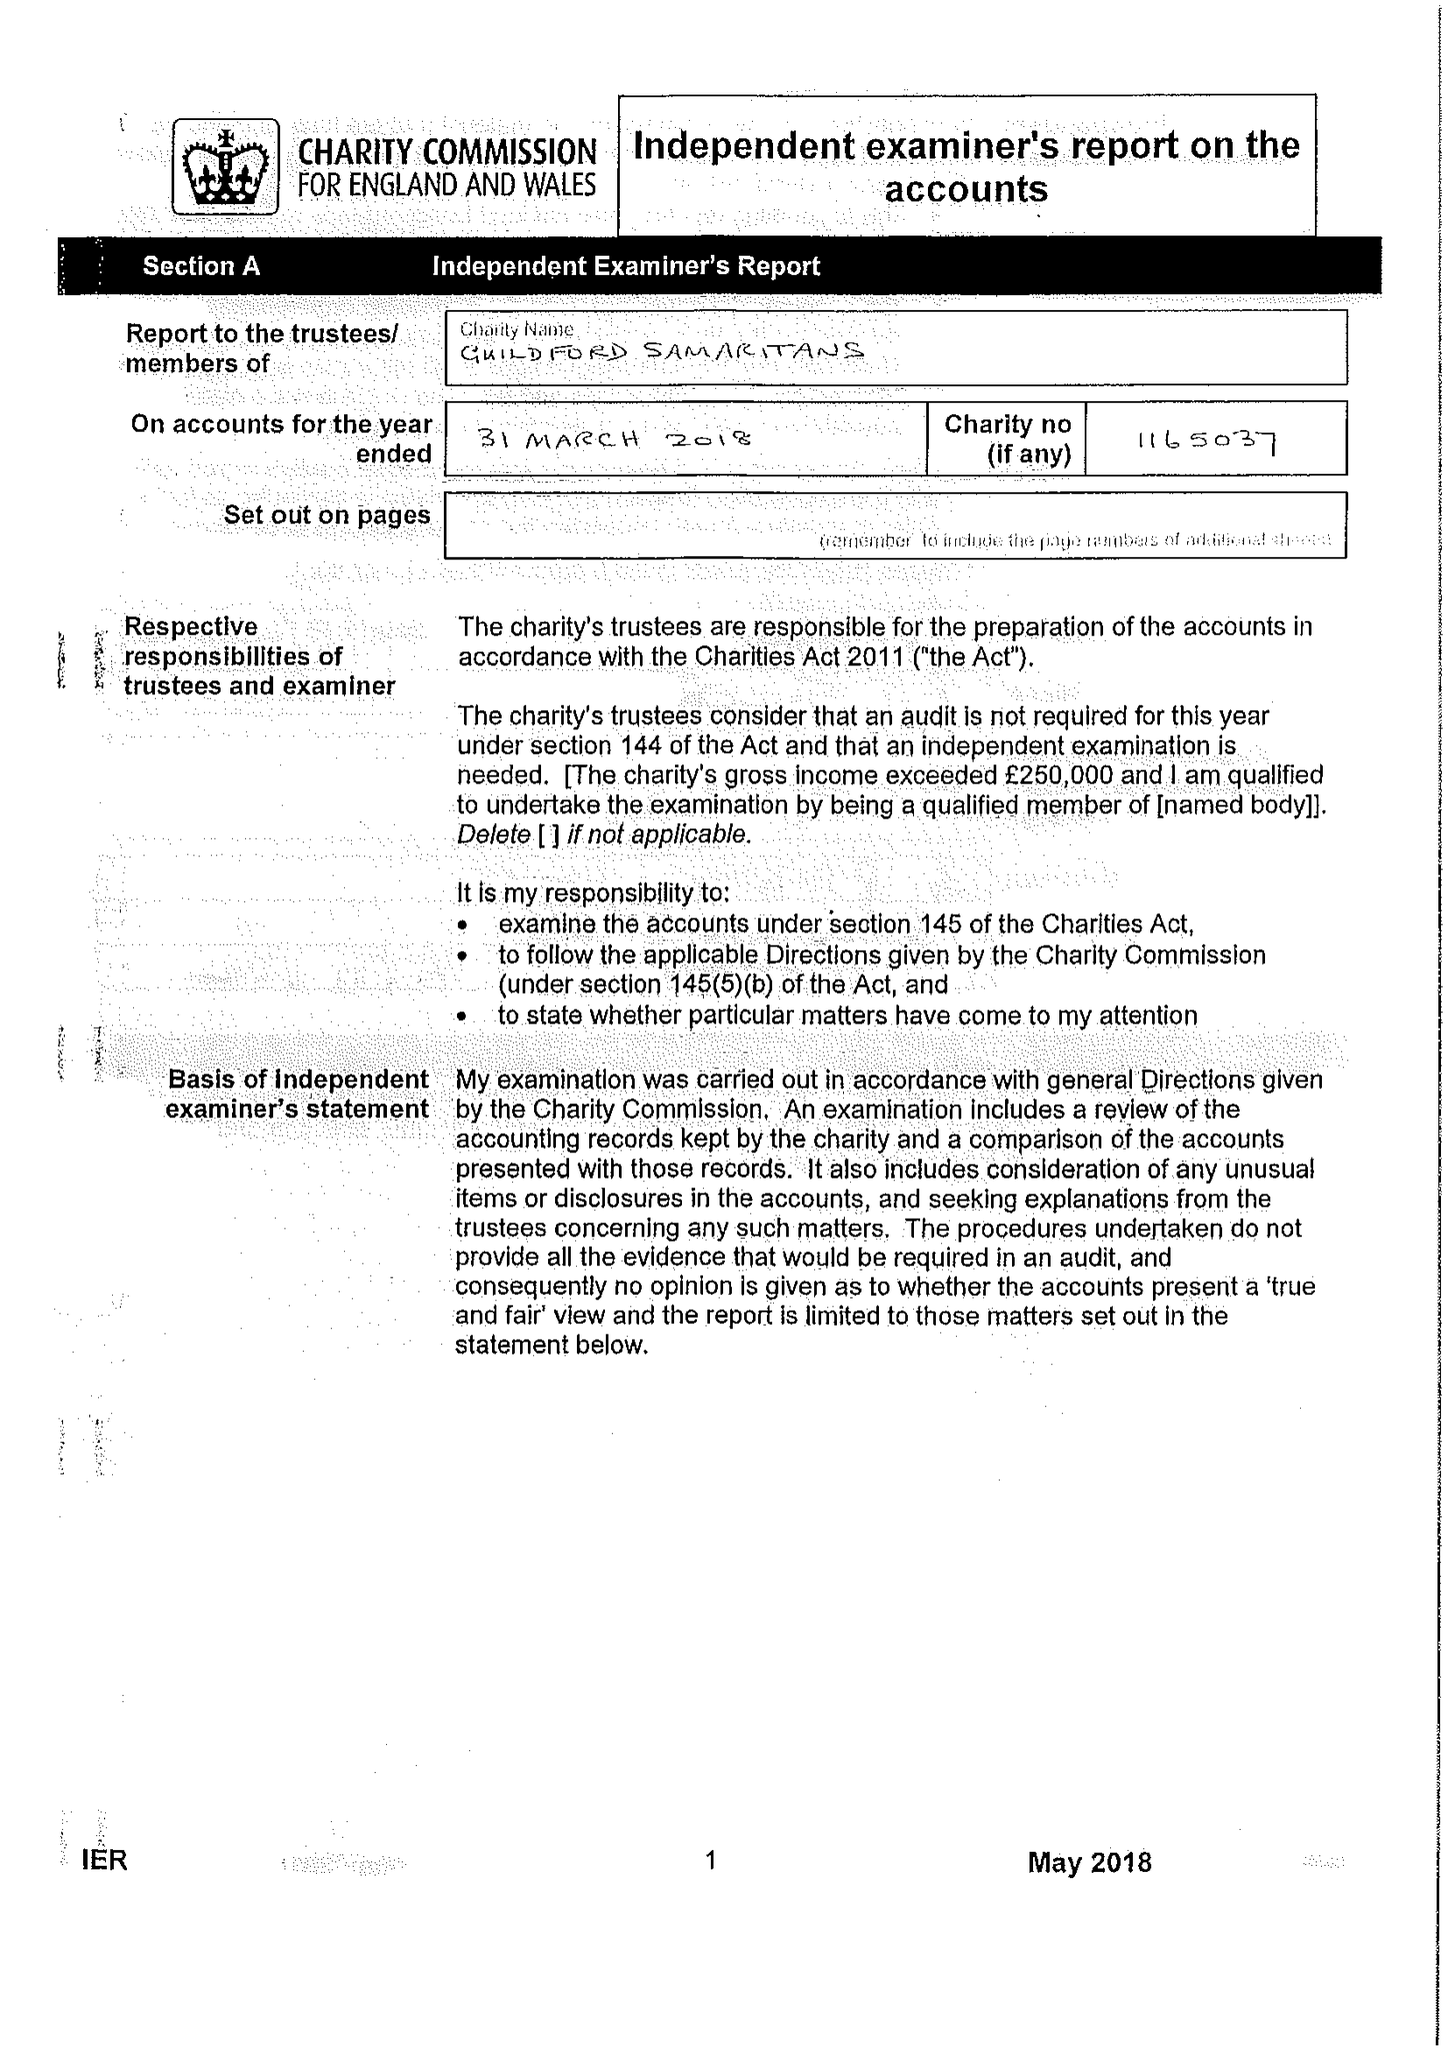What is the value for the charity_name?
Answer the question using a single word or phrase. Guildford Samaritans 